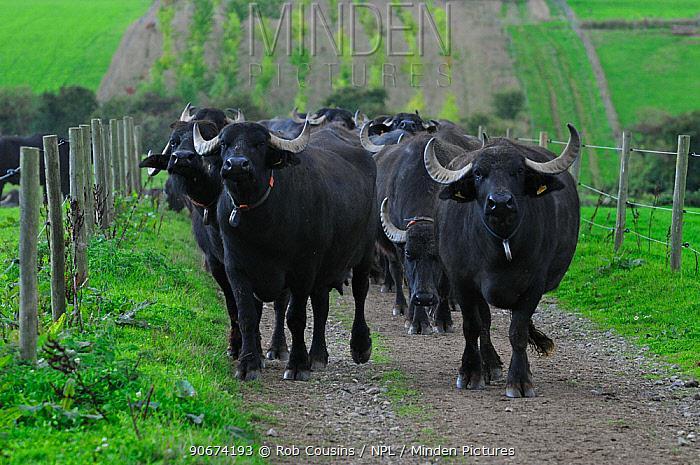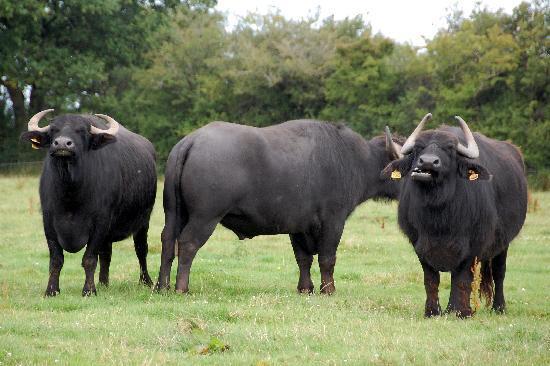The first image is the image on the left, the second image is the image on the right. For the images shown, is this caption "In one image there are at least three standing water buffaloes where one is facing a different direction than the others." true? Answer yes or no. Yes. The first image is the image on the left, the second image is the image on the right. For the images displayed, is the sentence "The left image contains only very dark hooved animals surrounded by bright green grass, with the foreground animals facing directly forward." factually correct? Answer yes or no. Yes. 